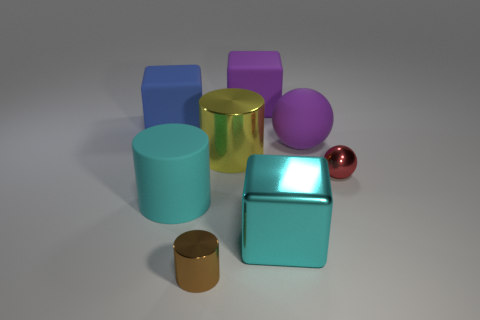What is the material of the object that is the same color as the matte cylinder?
Keep it short and to the point. Metal. What size is the purple object that is in front of the matte block in front of the large purple block?
Offer a very short reply. Large. How many small objects are yellow cylinders or brown rubber blocks?
Your response must be concise. 0. Are there fewer big cyan cubes than shiny things?
Your response must be concise. Yes. Is the small shiny ball the same color as the big shiny cylinder?
Make the answer very short. No. Is the number of tiny red metallic objects greater than the number of spheres?
Ensure brevity in your answer.  No. How many other things are the same color as the rubber cylinder?
Provide a succinct answer. 1. There is a purple rubber ball in front of the blue object; how many cubes are in front of it?
Your response must be concise. 1. There is a metallic ball; are there any small shiny objects on the left side of it?
Your answer should be compact. Yes. What is the shape of the purple matte object in front of the big purple object left of the large purple sphere?
Offer a terse response. Sphere. 